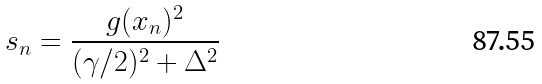<formula> <loc_0><loc_0><loc_500><loc_500>s _ { n } = \frac { g ( x _ { n } ) ^ { 2 } } { ( \gamma / 2 ) ^ { 2 } + \Delta ^ { 2 } }</formula> 